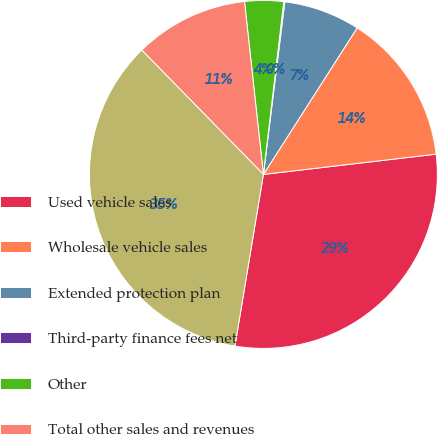<chart> <loc_0><loc_0><loc_500><loc_500><pie_chart><fcel>Used vehicle sales<fcel>Wholesale vehicle sales<fcel>Extended protection plan<fcel>Third-party finance fees net<fcel>Other<fcel>Total other sales and revenues<fcel>Total net sales and operating<nl><fcel>29.47%<fcel>14.08%<fcel>7.09%<fcel>0.1%<fcel>3.6%<fcel>10.59%<fcel>35.06%<nl></chart> 